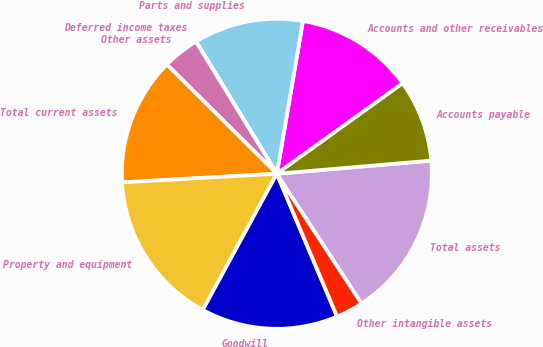Convert chart to OTSL. <chart><loc_0><loc_0><loc_500><loc_500><pie_chart><fcel>Accounts and other receivables<fcel>Parts and supplies<fcel>Deferred income taxes<fcel>Other assets<fcel>Total current assets<fcel>Property and equipment<fcel>Goodwill<fcel>Other intangible assets<fcel>Total assets<fcel>Accounts payable<nl><fcel>12.38%<fcel>11.43%<fcel>0.01%<fcel>3.81%<fcel>13.33%<fcel>16.19%<fcel>14.28%<fcel>2.86%<fcel>17.14%<fcel>8.57%<nl></chart> 